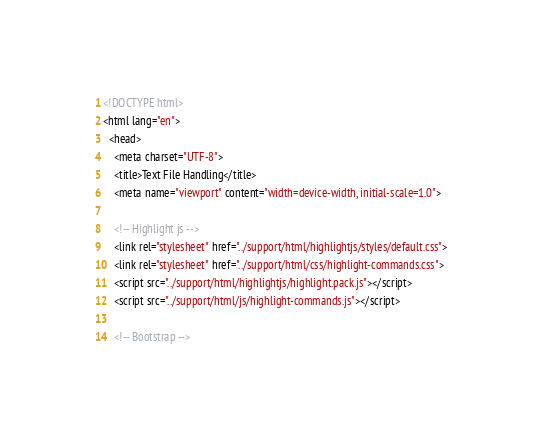<code> <loc_0><loc_0><loc_500><loc_500><_HTML_><!DOCTYPE html>
<html lang="en">
  <head>
    <meta charset="UTF-8">
    <title>Text File Handling</title>
    <meta name="viewport" content="width=device-width, initial-scale=1.0">

    <!-- Highlight js -->
    <link rel="stylesheet" href="../support/html/highlightjs/styles/default.css">
    <link rel="stylesheet" href="../support/html/css/highlight-commands.css">
    <script src="../support/html/highlightjs/highlight.pack.js"></script>
    <script src="../support/html/js/highlight-commands.js"></script>

    <!-- Bootstrap --></code> 